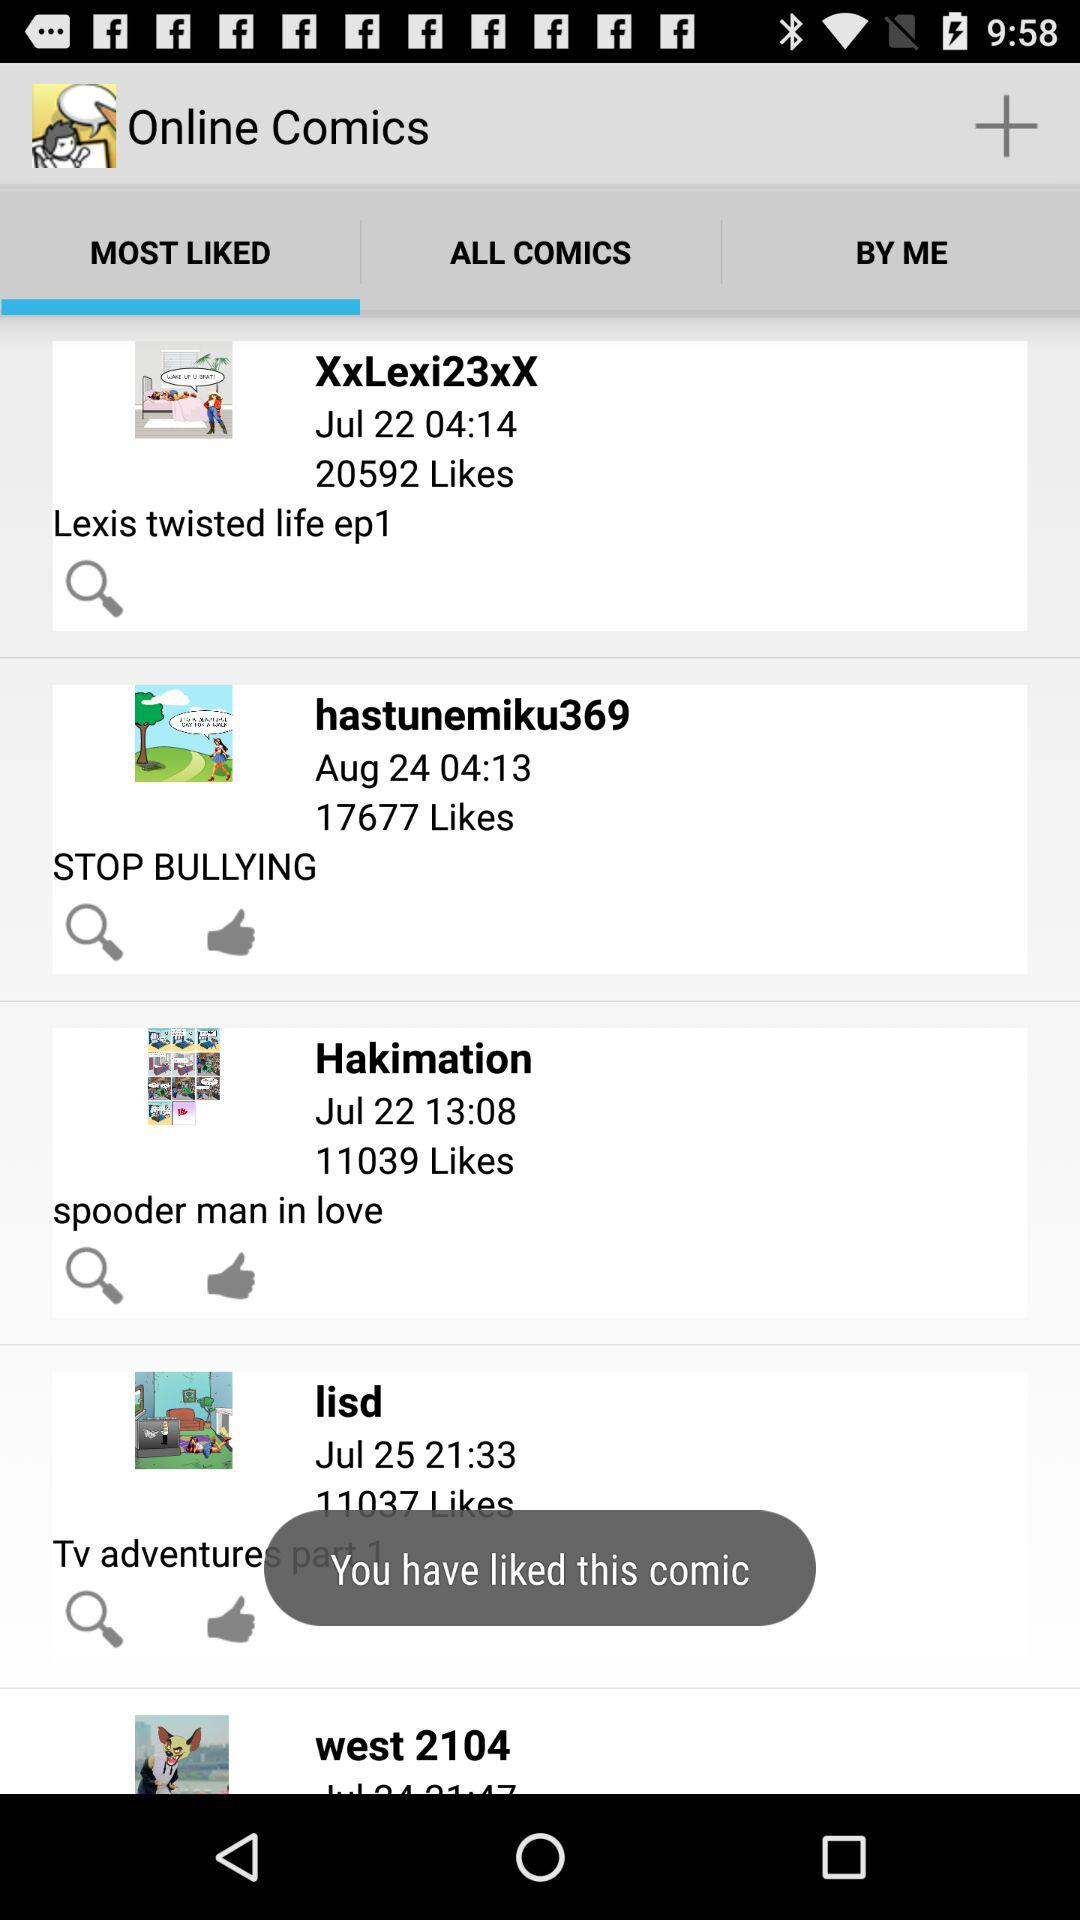What is the selected date for "hastunemiku369"? The selected date is August 24. 